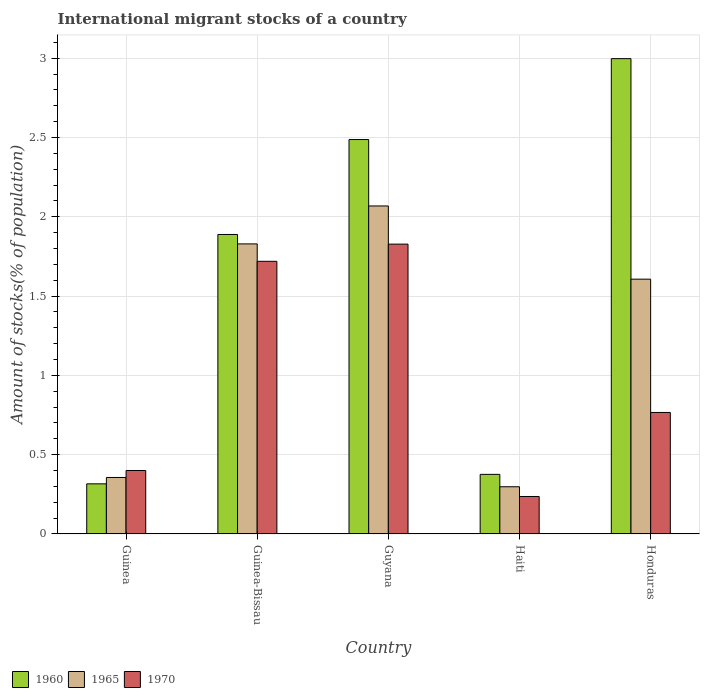How many groups of bars are there?
Provide a short and direct response. 5. How many bars are there on the 2nd tick from the right?
Provide a succinct answer. 3. What is the label of the 4th group of bars from the left?
Your response must be concise. Haiti. In how many cases, is the number of bars for a given country not equal to the number of legend labels?
Your response must be concise. 0. What is the amount of stocks in in 1970 in Honduras?
Offer a very short reply. 0.77. Across all countries, what is the maximum amount of stocks in in 1960?
Your answer should be very brief. 3. Across all countries, what is the minimum amount of stocks in in 1965?
Keep it short and to the point. 0.3. In which country was the amount of stocks in in 1965 maximum?
Keep it short and to the point. Guyana. In which country was the amount of stocks in in 1970 minimum?
Provide a short and direct response. Haiti. What is the total amount of stocks in in 1960 in the graph?
Ensure brevity in your answer.  8.07. What is the difference between the amount of stocks in in 1960 in Guinea and that in Guinea-Bissau?
Make the answer very short. -1.57. What is the difference between the amount of stocks in in 1960 in Guyana and the amount of stocks in in 1970 in Honduras?
Your response must be concise. 1.72. What is the average amount of stocks in in 1965 per country?
Keep it short and to the point. 1.23. What is the difference between the amount of stocks in of/in 1970 and amount of stocks in of/in 1965 in Guyana?
Ensure brevity in your answer.  -0.24. In how many countries, is the amount of stocks in in 1970 greater than 1.7 %?
Offer a very short reply. 2. What is the ratio of the amount of stocks in in 1970 in Guinea to that in Guinea-Bissau?
Your response must be concise. 0.23. Is the difference between the amount of stocks in in 1970 in Guinea and Guyana greater than the difference between the amount of stocks in in 1965 in Guinea and Guyana?
Offer a very short reply. Yes. What is the difference between the highest and the second highest amount of stocks in in 1965?
Offer a terse response. -0.24. What is the difference between the highest and the lowest amount of stocks in in 1960?
Your answer should be compact. 2.68. Is the sum of the amount of stocks in in 1965 in Guinea and Guinea-Bissau greater than the maximum amount of stocks in in 1970 across all countries?
Your answer should be compact. Yes. What does the 2nd bar from the left in Honduras represents?
Keep it short and to the point. 1965. Is it the case that in every country, the sum of the amount of stocks in in 1960 and amount of stocks in in 1965 is greater than the amount of stocks in in 1970?
Ensure brevity in your answer.  Yes. How many bars are there?
Your answer should be compact. 15. Are all the bars in the graph horizontal?
Your answer should be compact. No. Are the values on the major ticks of Y-axis written in scientific E-notation?
Provide a short and direct response. No. Does the graph contain grids?
Your answer should be very brief. Yes. How many legend labels are there?
Your answer should be compact. 3. What is the title of the graph?
Provide a succinct answer. International migrant stocks of a country. What is the label or title of the Y-axis?
Your response must be concise. Amount of stocks(% of population). What is the Amount of stocks(% of population) of 1960 in Guinea?
Keep it short and to the point. 0.32. What is the Amount of stocks(% of population) of 1965 in Guinea?
Offer a very short reply. 0.36. What is the Amount of stocks(% of population) of 1970 in Guinea?
Give a very brief answer. 0.4. What is the Amount of stocks(% of population) in 1960 in Guinea-Bissau?
Provide a short and direct response. 1.89. What is the Amount of stocks(% of population) of 1965 in Guinea-Bissau?
Your answer should be compact. 1.83. What is the Amount of stocks(% of population) of 1970 in Guinea-Bissau?
Provide a succinct answer. 1.72. What is the Amount of stocks(% of population) of 1960 in Guyana?
Ensure brevity in your answer.  2.49. What is the Amount of stocks(% of population) of 1965 in Guyana?
Make the answer very short. 2.07. What is the Amount of stocks(% of population) of 1970 in Guyana?
Your answer should be very brief. 1.83. What is the Amount of stocks(% of population) in 1960 in Haiti?
Offer a terse response. 0.38. What is the Amount of stocks(% of population) of 1965 in Haiti?
Offer a terse response. 0.3. What is the Amount of stocks(% of population) in 1970 in Haiti?
Ensure brevity in your answer.  0.24. What is the Amount of stocks(% of population) in 1960 in Honduras?
Keep it short and to the point. 3. What is the Amount of stocks(% of population) of 1965 in Honduras?
Provide a short and direct response. 1.61. What is the Amount of stocks(% of population) of 1970 in Honduras?
Provide a succinct answer. 0.77. Across all countries, what is the maximum Amount of stocks(% of population) in 1960?
Make the answer very short. 3. Across all countries, what is the maximum Amount of stocks(% of population) of 1965?
Offer a terse response. 2.07. Across all countries, what is the maximum Amount of stocks(% of population) in 1970?
Offer a terse response. 1.83. Across all countries, what is the minimum Amount of stocks(% of population) of 1960?
Your answer should be very brief. 0.32. Across all countries, what is the minimum Amount of stocks(% of population) in 1965?
Ensure brevity in your answer.  0.3. Across all countries, what is the minimum Amount of stocks(% of population) in 1970?
Offer a very short reply. 0.24. What is the total Amount of stocks(% of population) in 1960 in the graph?
Give a very brief answer. 8.07. What is the total Amount of stocks(% of population) of 1965 in the graph?
Your answer should be compact. 6.16. What is the total Amount of stocks(% of population) in 1970 in the graph?
Offer a terse response. 4.95. What is the difference between the Amount of stocks(% of population) in 1960 in Guinea and that in Guinea-Bissau?
Give a very brief answer. -1.57. What is the difference between the Amount of stocks(% of population) in 1965 in Guinea and that in Guinea-Bissau?
Your answer should be compact. -1.47. What is the difference between the Amount of stocks(% of population) in 1970 in Guinea and that in Guinea-Bissau?
Provide a succinct answer. -1.32. What is the difference between the Amount of stocks(% of population) in 1960 in Guinea and that in Guyana?
Make the answer very short. -2.17. What is the difference between the Amount of stocks(% of population) in 1965 in Guinea and that in Guyana?
Your answer should be very brief. -1.71. What is the difference between the Amount of stocks(% of population) in 1970 in Guinea and that in Guyana?
Offer a very short reply. -1.43. What is the difference between the Amount of stocks(% of population) in 1960 in Guinea and that in Haiti?
Make the answer very short. -0.06. What is the difference between the Amount of stocks(% of population) in 1965 in Guinea and that in Haiti?
Offer a terse response. 0.06. What is the difference between the Amount of stocks(% of population) in 1970 in Guinea and that in Haiti?
Make the answer very short. 0.16. What is the difference between the Amount of stocks(% of population) in 1960 in Guinea and that in Honduras?
Offer a terse response. -2.68. What is the difference between the Amount of stocks(% of population) in 1965 in Guinea and that in Honduras?
Your answer should be very brief. -1.25. What is the difference between the Amount of stocks(% of population) in 1970 in Guinea and that in Honduras?
Keep it short and to the point. -0.37. What is the difference between the Amount of stocks(% of population) in 1960 in Guinea-Bissau and that in Guyana?
Offer a very short reply. -0.6. What is the difference between the Amount of stocks(% of population) in 1965 in Guinea-Bissau and that in Guyana?
Offer a terse response. -0.24. What is the difference between the Amount of stocks(% of population) of 1970 in Guinea-Bissau and that in Guyana?
Provide a short and direct response. -0.11. What is the difference between the Amount of stocks(% of population) of 1960 in Guinea-Bissau and that in Haiti?
Keep it short and to the point. 1.51. What is the difference between the Amount of stocks(% of population) of 1965 in Guinea-Bissau and that in Haiti?
Ensure brevity in your answer.  1.53. What is the difference between the Amount of stocks(% of population) of 1970 in Guinea-Bissau and that in Haiti?
Offer a terse response. 1.48. What is the difference between the Amount of stocks(% of population) in 1960 in Guinea-Bissau and that in Honduras?
Your answer should be very brief. -1.11. What is the difference between the Amount of stocks(% of population) of 1965 in Guinea-Bissau and that in Honduras?
Keep it short and to the point. 0.22. What is the difference between the Amount of stocks(% of population) of 1970 in Guinea-Bissau and that in Honduras?
Ensure brevity in your answer.  0.95. What is the difference between the Amount of stocks(% of population) in 1960 in Guyana and that in Haiti?
Your response must be concise. 2.11. What is the difference between the Amount of stocks(% of population) of 1965 in Guyana and that in Haiti?
Ensure brevity in your answer.  1.77. What is the difference between the Amount of stocks(% of population) in 1970 in Guyana and that in Haiti?
Your answer should be compact. 1.59. What is the difference between the Amount of stocks(% of population) of 1960 in Guyana and that in Honduras?
Ensure brevity in your answer.  -0.51. What is the difference between the Amount of stocks(% of population) in 1965 in Guyana and that in Honduras?
Ensure brevity in your answer.  0.46. What is the difference between the Amount of stocks(% of population) in 1970 in Guyana and that in Honduras?
Give a very brief answer. 1.06. What is the difference between the Amount of stocks(% of population) of 1960 in Haiti and that in Honduras?
Your answer should be compact. -2.62. What is the difference between the Amount of stocks(% of population) of 1965 in Haiti and that in Honduras?
Provide a succinct answer. -1.31. What is the difference between the Amount of stocks(% of population) of 1970 in Haiti and that in Honduras?
Provide a succinct answer. -0.53. What is the difference between the Amount of stocks(% of population) in 1960 in Guinea and the Amount of stocks(% of population) in 1965 in Guinea-Bissau?
Make the answer very short. -1.51. What is the difference between the Amount of stocks(% of population) of 1960 in Guinea and the Amount of stocks(% of population) of 1970 in Guinea-Bissau?
Provide a short and direct response. -1.4. What is the difference between the Amount of stocks(% of population) of 1965 in Guinea and the Amount of stocks(% of population) of 1970 in Guinea-Bissau?
Offer a very short reply. -1.36. What is the difference between the Amount of stocks(% of population) in 1960 in Guinea and the Amount of stocks(% of population) in 1965 in Guyana?
Keep it short and to the point. -1.75. What is the difference between the Amount of stocks(% of population) of 1960 in Guinea and the Amount of stocks(% of population) of 1970 in Guyana?
Keep it short and to the point. -1.51. What is the difference between the Amount of stocks(% of population) of 1965 in Guinea and the Amount of stocks(% of population) of 1970 in Guyana?
Provide a short and direct response. -1.47. What is the difference between the Amount of stocks(% of population) of 1960 in Guinea and the Amount of stocks(% of population) of 1965 in Haiti?
Make the answer very short. 0.02. What is the difference between the Amount of stocks(% of population) in 1960 in Guinea and the Amount of stocks(% of population) in 1970 in Haiti?
Provide a short and direct response. 0.08. What is the difference between the Amount of stocks(% of population) of 1965 in Guinea and the Amount of stocks(% of population) of 1970 in Haiti?
Ensure brevity in your answer.  0.12. What is the difference between the Amount of stocks(% of population) in 1960 in Guinea and the Amount of stocks(% of population) in 1965 in Honduras?
Provide a succinct answer. -1.29. What is the difference between the Amount of stocks(% of population) in 1960 in Guinea and the Amount of stocks(% of population) in 1970 in Honduras?
Your answer should be compact. -0.45. What is the difference between the Amount of stocks(% of population) of 1965 in Guinea and the Amount of stocks(% of population) of 1970 in Honduras?
Keep it short and to the point. -0.41. What is the difference between the Amount of stocks(% of population) in 1960 in Guinea-Bissau and the Amount of stocks(% of population) in 1965 in Guyana?
Give a very brief answer. -0.18. What is the difference between the Amount of stocks(% of population) of 1960 in Guinea-Bissau and the Amount of stocks(% of population) of 1970 in Guyana?
Offer a terse response. 0.06. What is the difference between the Amount of stocks(% of population) in 1965 in Guinea-Bissau and the Amount of stocks(% of population) in 1970 in Guyana?
Make the answer very short. 0. What is the difference between the Amount of stocks(% of population) of 1960 in Guinea-Bissau and the Amount of stocks(% of population) of 1965 in Haiti?
Give a very brief answer. 1.59. What is the difference between the Amount of stocks(% of population) of 1960 in Guinea-Bissau and the Amount of stocks(% of population) of 1970 in Haiti?
Keep it short and to the point. 1.65. What is the difference between the Amount of stocks(% of population) in 1965 in Guinea-Bissau and the Amount of stocks(% of population) in 1970 in Haiti?
Make the answer very short. 1.59. What is the difference between the Amount of stocks(% of population) in 1960 in Guinea-Bissau and the Amount of stocks(% of population) in 1965 in Honduras?
Your answer should be compact. 0.28. What is the difference between the Amount of stocks(% of population) in 1960 in Guinea-Bissau and the Amount of stocks(% of population) in 1970 in Honduras?
Ensure brevity in your answer.  1.12. What is the difference between the Amount of stocks(% of population) in 1965 in Guinea-Bissau and the Amount of stocks(% of population) in 1970 in Honduras?
Your answer should be very brief. 1.06. What is the difference between the Amount of stocks(% of population) of 1960 in Guyana and the Amount of stocks(% of population) of 1965 in Haiti?
Your answer should be very brief. 2.19. What is the difference between the Amount of stocks(% of population) of 1960 in Guyana and the Amount of stocks(% of population) of 1970 in Haiti?
Provide a succinct answer. 2.25. What is the difference between the Amount of stocks(% of population) of 1965 in Guyana and the Amount of stocks(% of population) of 1970 in Haiti?
Your answer should be very brief. 1.83. What is the difference between the Amount of stocks(% of population) in 1960 in Guyana and the Amount of stocks(% of population) in 1965 in Honduras?
Offer a very short reply. 0.88. What is the difference between the Amount of stocks(% of population) in 1960 in Guyana and the Amount of stocks(% of population) in 1970 in Honduras?
Offer a very short reply. 1.72. What is the difference between the Amount of stocks(% of population) of 1965 in Guyana and the Amount of stocks(% of population) of 1970 in Honduras?
Make the answer very short. 1.3. What is the difference between the Amount of stocks(% of population) in 1960 in Haiti and the Amount of stocks(% of population) in 1965 in Honduras?
Ensure brevity in your answer.  -1.23. What is the difference between the Amount of stocks(% of population) of 1960 in Haiti and the Amount of stocks(% of population) of 1970 in Honduras?
Offer a terse response. -0.39. What is the difference between the Amount of stocks(% of population) of 1965 in Haiti and the Amount of stocks(% of population) of 1970 in Honduras?
Ensure brevity in your answer.  -0.47. What is the average Amount of stocks(% of population) in 1960 per country?
Your answer should be compact. 1.61. What is the average Amount of stocks(% of population) in 1965 per country?
Keep it short and to the point. 1.23. What is the average Amount of stocks(% of population) of 1970 per country?
Your answer should be very brief. 0.99. What is the difference between the Amount of stocks(% of population) of 1960 and Amount of stocks(% of population) of 1965 in Guinea?
Your answer should be very brief. -0.04. What is the difference between the Amount of stocks(% of population) in 1960 and Amount of stocks(% of population) in 1970 in Guinea?
Keep it short and to the point. -0.08. What is the difference between the Amount of stocks(% of population) of 1965 and Amount of stocks(% of population) of 1970 in Guinea?
Keep it short and to the point. -0.04. What is the difference between the Amount of stocks(% of population) of 1960 and Amount of stocks(% of population) of 1965 in Guinea-Bissau?
Provide a succinct answer. 0.06. What is the difference between the Amount of stocks(% of population) in 1960 and Amount of stocks(% of population) in 1970 in Guinea-Bissau?
Your response must be concise. 0.17. What is the difference between the Amount of stocks(% of population) of 1965 and Amount of stocks(% of population) of 1970 in Guinea-Bissau?
Ensure brevity in your answer.  0.11. What is the difference between the Amount of stocks(% of population) in 1960 and Amount of stocks(% of population) in 1965 in Guyana?
Make the answer very short. 0.42. What is the difference between the Amount of stocks(% of population) in 1960 and Amount of stocks(% of population) in 1970 in Guyana?
Provide a succinct answer. 0.66. What is the difference between the Amount of stocks(% of population) in 1965 and Amount of stocks(% of population) in 1970 in Guyana?
Give a very brief answer. 0.24. What is the difference between the Amount of stocks(% of population) in 1960 and Amount of stocks(% of population) in 1965 in Haiti?
Give a very brief answer. 0.08. What is the difference between the Amount of stocks(% of population) of 1960 and Amount of stocks(% of population) of 1970 in Haiti?
Ensure brevity in your answer.  0.14. What is the difference between the Amount of stocks(% of population) of 1965 and Amount of stocks(% of population) of 1970 in Haiti?
Your answer should be compact. 0.06. What is the difference between the Amount of stocks(% of population) in 1960 and Amount of stocks(% of population) in 1965 in Honduras?
Your response must be concise. 1.39. What is the difference between the Amount of stocks(% of population) of 1960 and Amount of stocks(% of population) of 1970 in Honduras?
Ensure brevity in your answer.  2.23. What is the difference between the Amount of stocks(% of population) of 1965 and Amount of stocks(% of population) of 1970 in Honduras?
Your answer should be compact. 0.84. What is the ratio of the Amount of stocks(% of population) in 1960 in Guinea to that in Guinea-Bissau?
Give a very brief answer. 0.17. What is the ratio of the Amount of stocks(% of population) of 1965 in Guinea to that in Guinea-Bissau?
Ensure brevity in your answer.  0.19. What is the ratio of the Amount of stocks(% of population) of 1970 in Guinea to that in Guinea-Bissau?
Offer a terse response. 0.23. What is the ratio of the Amount of stocks(% of population) of 1960 in Guinea to that in Guyana?
Offer a terse response. 0.13. What is the ratio of the Amount of stocks(% of population) of 1965 in Guinea to that in Guyana?
Your answer should be very brief. 0.17. What is the ratio of the Amount of stocks(% of population) of 1970 in Guinea to that in Guyana?
Your answer should be very brief. 0.22. What is the ratio of the Amount of stocks(% of population) in 1960 in Guinea to that in Haiti?
Your answer should be very brief. 0.84. What is the ratio of the Amount of stocks(% of population) in 1965 in Guinea to that in Haiti?
Your answer should be compact. 1.2. What is the ratio of the Amount of stocks(% of population) of 1970 in Guinea to that in Haiti?
Provide a short and direct response. 1.69. What is the ratio of the Amount of stocks(% of population) in 1960 in Guinea to that in Honduras?
Your answer should be compact. 0.11. What is the ratio of the Amount of stocks(% of population) of 1965 in Guinea to that in Honduras?
Ensure brevity in your answer.  0.22. What is the ratio of the Amount of stocks(% of population) in 1970 in Guinea to that in Honduras?
Provide a short and direct response. 0.52. What is the ratio of the Amount of stocks(% of population) of 1960 in Guinea-Bissau to that in Guyana?
Keep it short and to the point. 0.76. What is the ratio of the Amount of stocks(% of population) of 1965 in Guinea-Bissau to that in Guyana?
Ensure brevity in your answer.  0.88. What is the ratio of the Amount of stocks(% of population) of 1970 in Guinea-Bissau to that in Guyana?
Ensure brevity in your answer.  0.94. What is the ratio of the Amount of stocks(% of population) in 1960 in Guinea-Bissau to that in Haiti?
Keep it short and to the point. 5.02. What is the ratio of the Amount of stocks(% of population) in 1965 in Guinea-Bissau to that in Haiti?
Your answer should be very brief. 6.14. What is the ratio of the Amount of stocks(% of population) of 1970 in Guinea-Bissau to that in Haiti?
Keep it short and to the point. 7.28. What is the ratio of the Amount of stocks(% of population) in 1960 in Guinea-Bissau to that in Honduras?
Your answer should be very brief. 0.63. What is the ratio of the Amount of stocks(% of population) in 1965 in Guinea-Bissau to that in Honduras?
Make the answer very short. 1.14. What is the ratio of the Amount of stocks(% of population) in 1970 in Guinea-Bissau to that in Honduras?
Give a very brief answer. 2.24. What is the ratio of the Amount of stocks(% of population) of 1960 in Guyana to that in Haiti?
Your answer should be very brief. 6.62. What is the ratio of the Amount of stocks(% of population) of 1965 in Guyana to that in Haiti?
Your response must be concise. 6.95. What is the ratio of the Amount of stocks(% of population) of 1970 in Guyana to that in Haiti?
Make the answer very short. 7.73. What is the ratio of the Amount of stocks(% of population) of 1960 in Guyana to that in Honduras?
Provide a succinct answer. 0.83. What is the ratio of the Amount of stocks(% of population) of 1965 in Guyana to that in Honduras?
Provide a short and direct response. 1.29. What is the ratio of the Amount of stocks(% of population) of 1970 in Guyana to that in Honduras?
Keep it short and to the point. 2.39. What is the ratio of the Amount of stocks(% of population) in 1960 in Haiti to that in Honduras?
Give a very brief answer. 0.13. What is the ratio of the Amount of stocks(% of population) in 1965 in Haiti to that in Honduras?
Your answer should be compact. 0.19. What is the ratio of the Amount of stocks(% of population) in 1970 in Haiti to that in Honduras?
Your answer should be compact. 0.31. What is the difference between the highest and the second highest Amount of stocks(% of population) in 1960?
Ensure brevity in your answer.  0.51. What is the difference between the highest and the second highest Amount of stocks(% of population) in 1965?
Your answer should be compact. 0.24. What is the difference between the highest and the second highest Amount of stocks(% of population) in 1970?
Provide a short and direct response. 0.11. What is the difference between the highest and the lowest Amount of stocks(% of population) in 1960?
Your response must be concise. 2.68. What is the difference between the highest and the lowest Amount of stocks(% of population) of 1965?
Your response must be concise. 1.77. What is the difference between the highest and the lowest Amount of stocks(% of population) of 1970?
Make the answer very short. 1.59. 